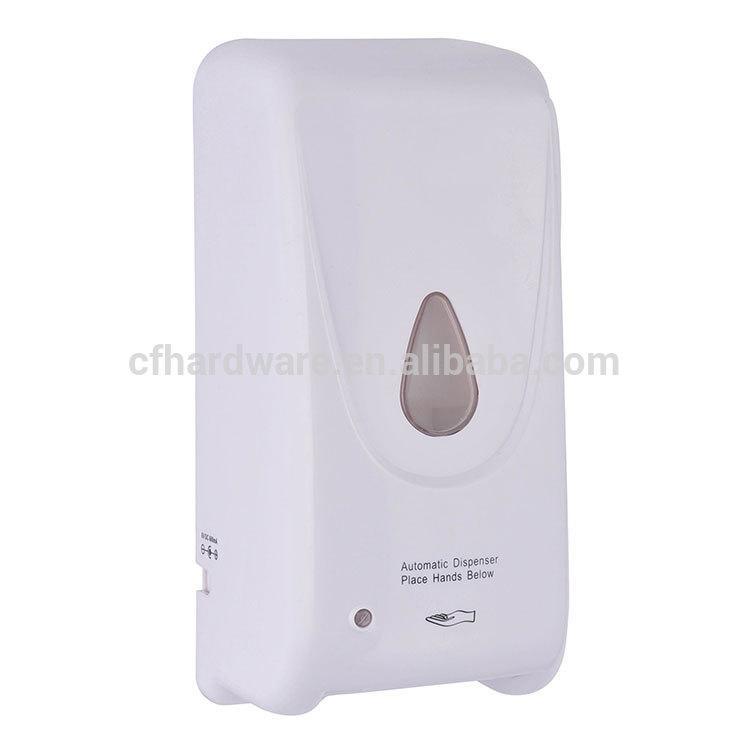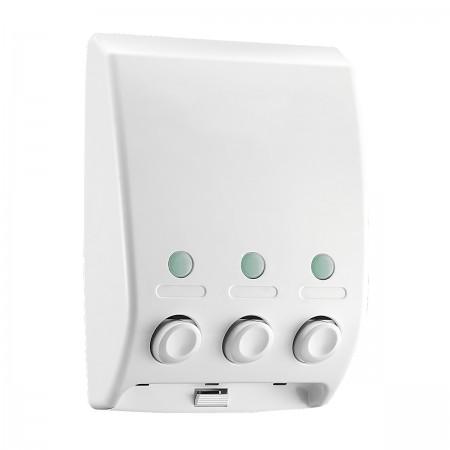The first image is the image on the left, the second image is the image on the right. Examine the images to the left and right. Is the description "The left image features a narrower rectangular dispenser with a circle above a dark rectangular button, and the right image features a more square dispenser with a rectangle above the rectangular button on the bottom." accurate? Answer yes or no. No. 